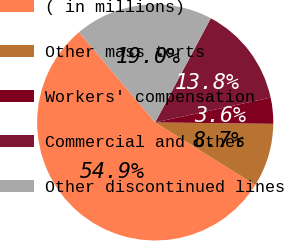Convert chart to OTSL. <chart><loc_0><loc_0><loc_500><loc_500><pie_chart><fcel>( in millions)<fcel>Other mass torts<fcel>Workers' compensation<fcel>Commercial and other<fcel>Other discontinued lines<nl><fcel>54.94%<fcel>8.7%<fcel>3.56%<fcel>13.83%<fcel>18.97%<nl></chart> 